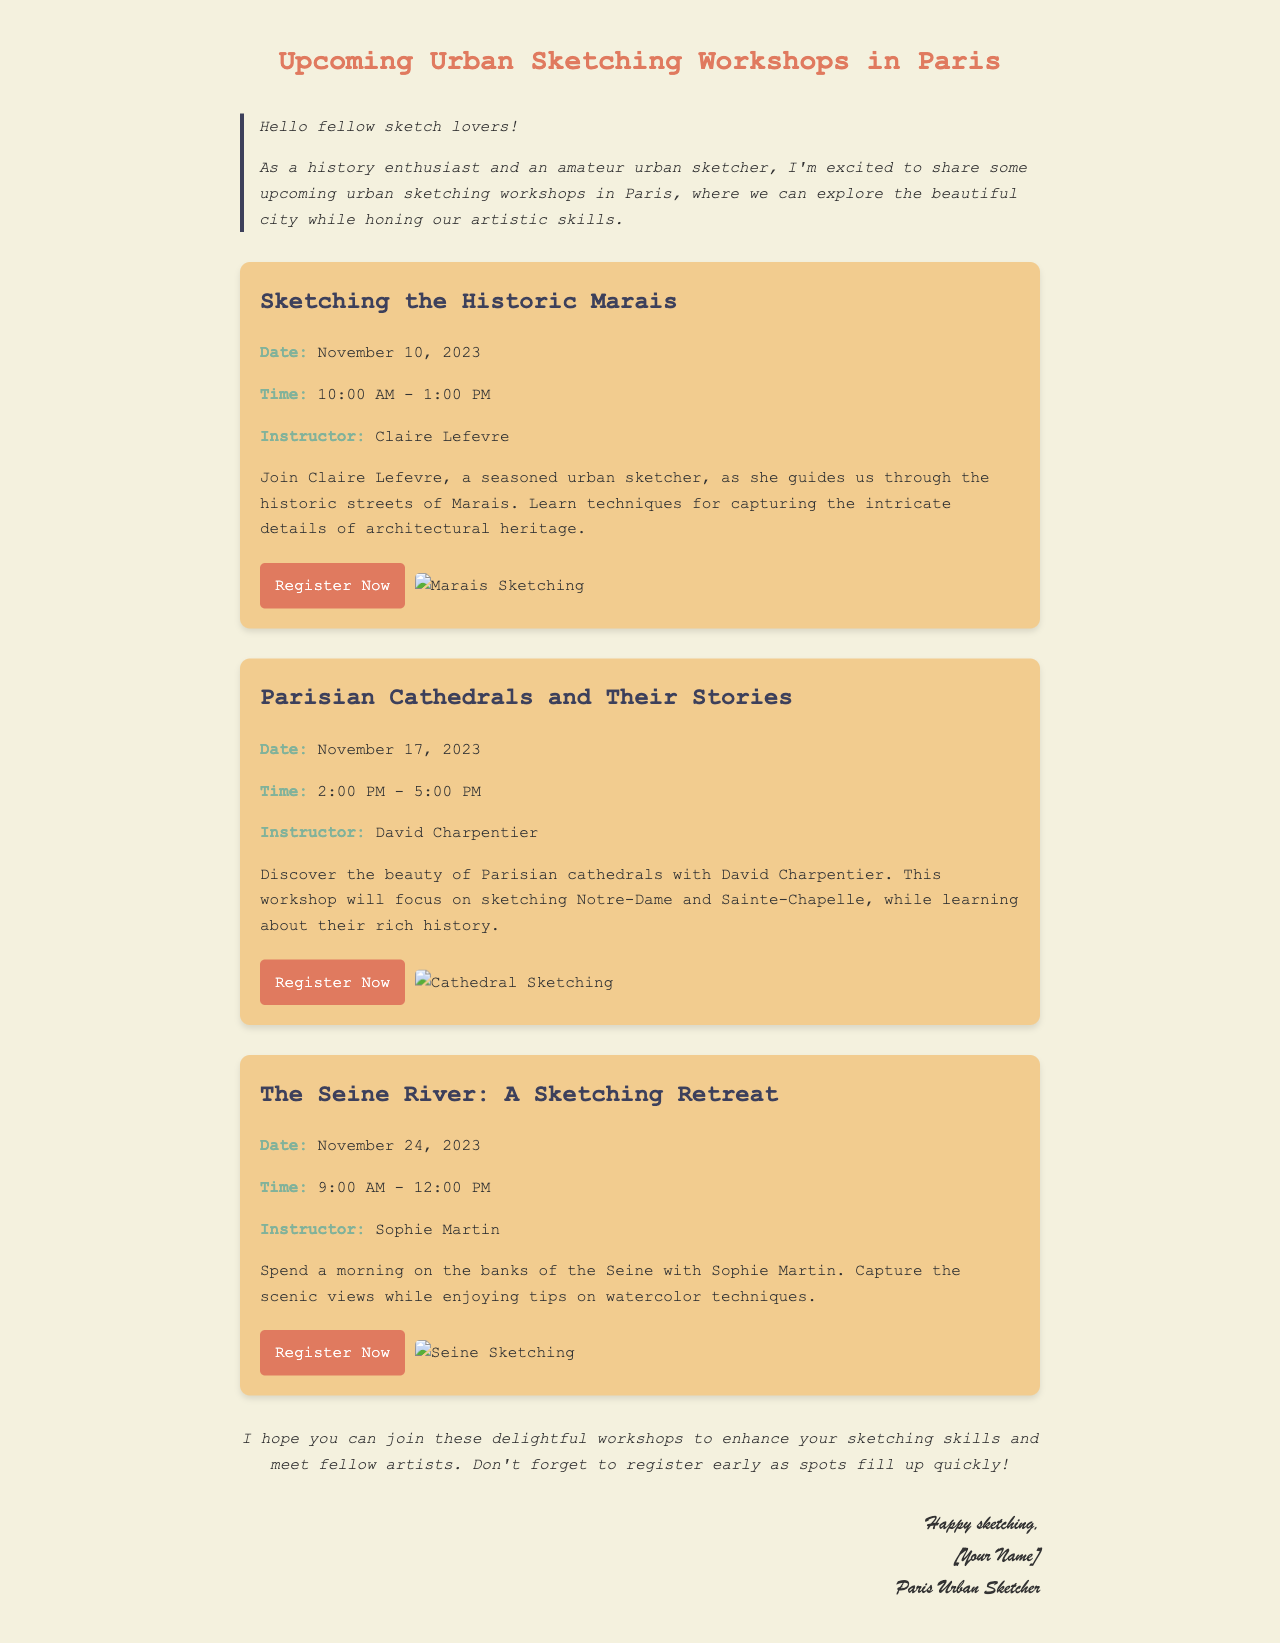What is the date of the workshop "Sketching the Historic Marais"? The document specifies that this workshop is scheduled for November 10, 2023.
Answer: November 10, 2023 Who is the instructor for the "Parisian Cathedrals and Their Stories" workshop? According to the document, the instructor for this workshop is David Charpentier.
Answer: David Charpentier What time does "The Seine River: A Sketching Retreat" workshop start? The workshop starts at 9:00 AM as listed in the details for the workshop.
Answer: 9:00 AM How many urban sketching workshops are mentioned in the email? The document lists three workshops, which can be counted from the content provided.
Answer: Three What technique will be focused on during the "The Seine River: A Sketching Retreat"? The description indicates that watercolor techniques will be a focus during this workshop.
Answer: Watercolor techniques Which workshop involves sketching Notre-Dame? The document states that Notre-Dame is part of the "Parisian Cathedrals and Their Stories" workshop.
Answer: Parisian Cathedrals and Their Stories 